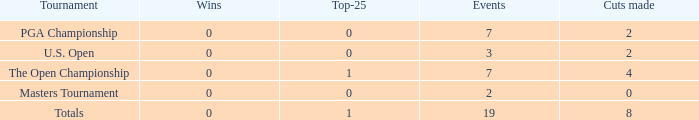What is the total number of cuts made of tournaments with 2 Events? 1.0. 